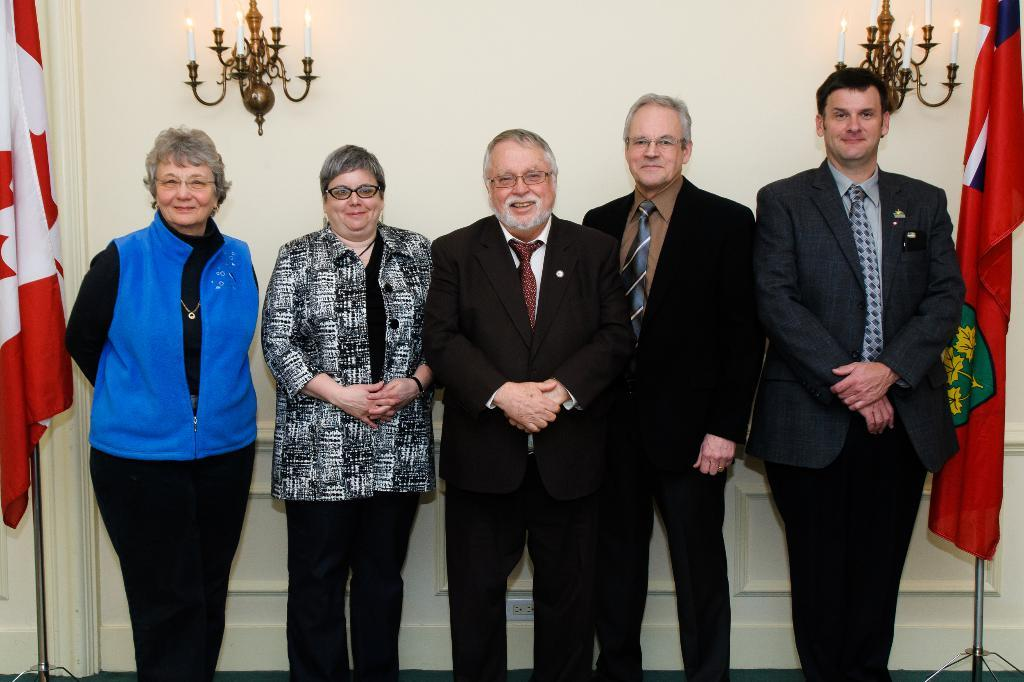What is happening in the image? There are people standing in the image. Can you describe the attire of the people? The people are wearing different color dresses. What can be seen on both sides of the image? There are flags on both sides of the image. What is visible in the background of the image? There is a white wall visible in the background. What is attached to the white wall? Candles are attached to the wall. How many voyages are depicted in the image? There is no voyage depicted in the image; it features people standing with flags and a wall with candles. What type of slip can be seen on the floor in the image? There is no slip present in the image. 